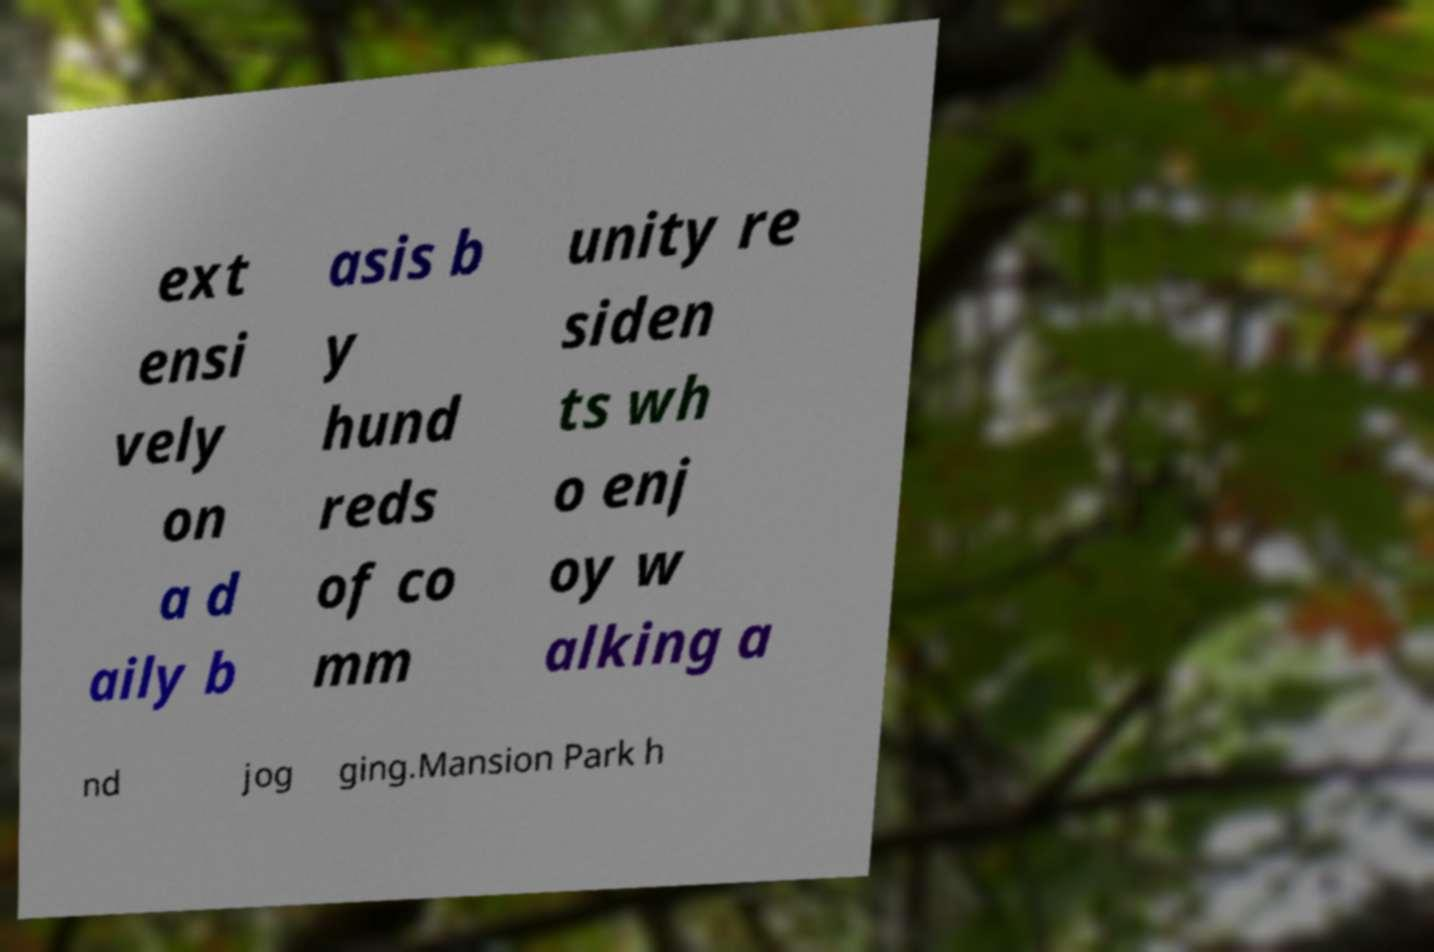Could you extract and type out the text from this image? ext ensi vely on a d aily b asis b y hund reds of co mm unity re siden ts wh o enj oy w alking a nd jog ging.Mansion Park h 